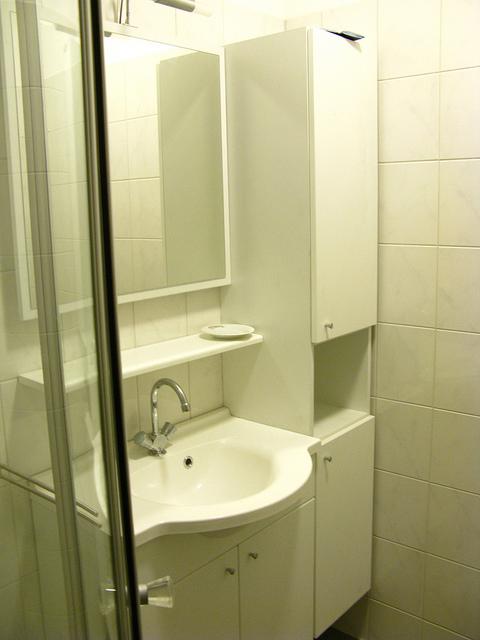Is there towels?
Answer briefly. No. Is the sink clean?
Answer briefly. Yes. Is there a mirror in the room?
Be succinct. Yes. 